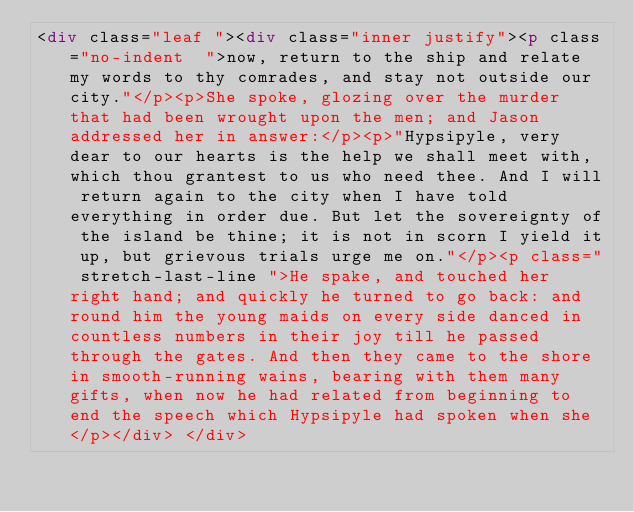<code> <loc_0><loc_0><loc_500><loc_500><_HTML_><div class="leaf "><div class="inner justify"><p class="no-indent  ">now, return to the ship and relate my words to thy comrades, and stay not outside our city."</p><p>She spoke, glozing over the murder that had been wrought upon the men; and Jason addressed her in answer:</p><p>"Hypsipyle, very dear to our hearts is the help we shall meet with, which thou grantest to us who need thee. And I will return again to the city when I have told everything in order due. But let the sovereignty of the island be thine; it is not in scorn I yield it up, but grievous trials urge me on."</p><p class=" stretch-last-line ">He spake, and touched her right hand; and quickly he turned to go back: and round him the young maids on every side danced in countless numbers in their joy till he passed through the gates. And then they came to the shore in smooth-running wains, bearing with them many gifts, when now he had related from beginning to end the speech which Hypsipyle had spoken when she</p></div> </div></code> 